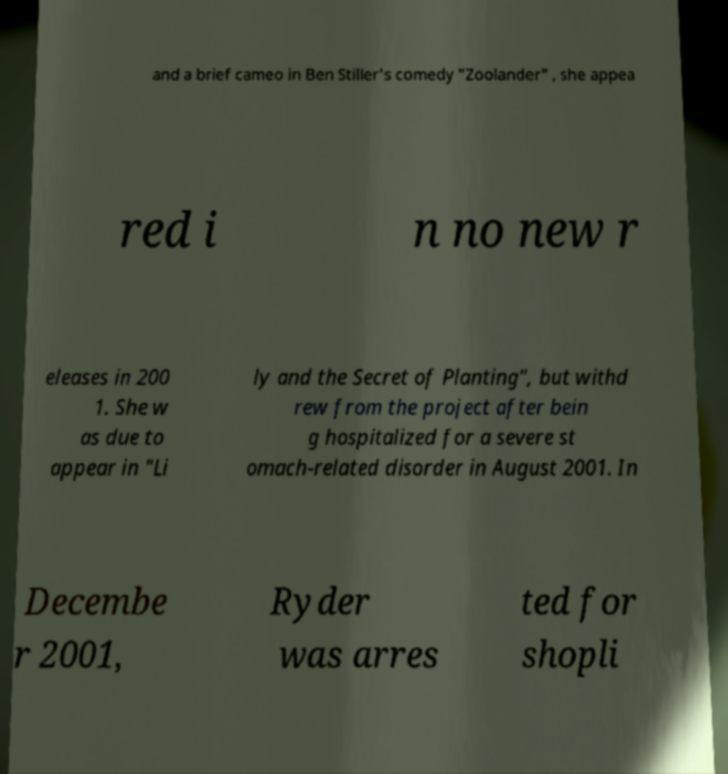Could you extract and type out the text from this image? and a brief cameo in Ben Stiller's comedy "Zoolander" , she appea red i n no new r eleases in 200 1. She w as due to appear in "Li ly and the Secret of Planting", but withd rew from the project after bein g hospitalized for a severe st omach-related disorder in August 2001. In Decembe r 2001, Ryder was arres ted for shopli 